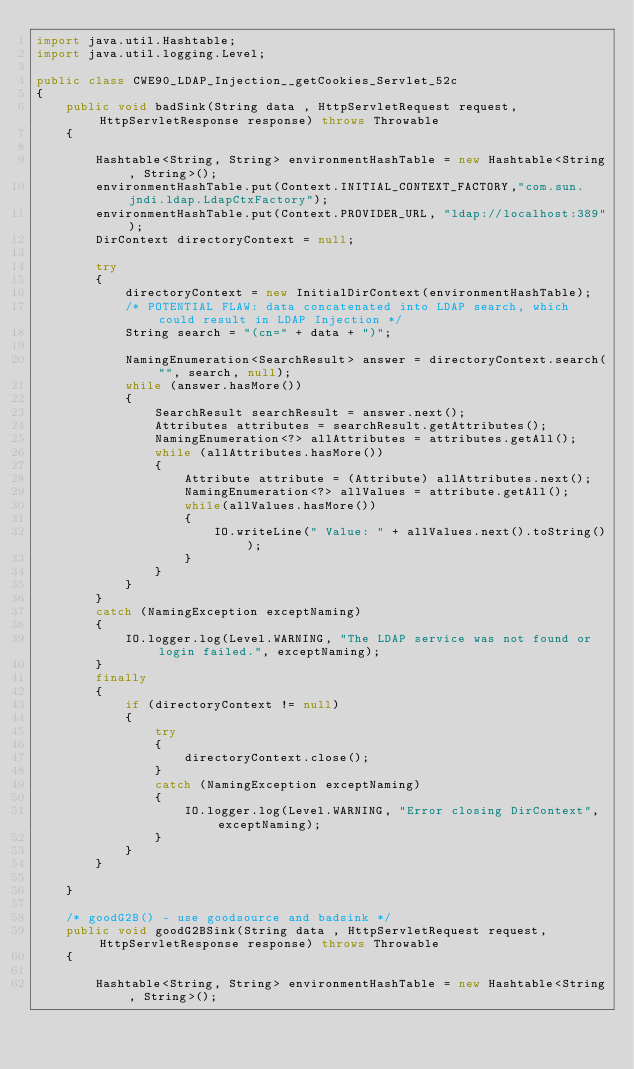Convert code to text. <code><loc_0><loc_0><loc_500><loc_500><_Java_>import java.util.Hashtable;
import java.util.logging.Level;

public class CWE90_LDAP_Injection__getCookies_Servlet_52c
{
    public void badSink(String data , HttpServletRequest request, HttpServletResponse response) throws Throwable
    {

        Hashtable<String, String> environmentHashTable = new Hashtable<String, String>();
        environmentHashTable.put(Context.INITIAL_CONTEXT_FACTORY,"com.sun.jndi.ldap.LdapCtxFactory");
        environmentHashTable.put(Context.PROVIDER_URL, "ldap://localhost:389");
        DirContext directoryContext = null;

        try
        {
            directoryContext = new InitialDirContext(environmentHashTable);
            /* POTENTIAL FLAW: data concatenated into LDAP search, which could result in LDAP Injection */
            String search = "(cn=" + data + ")";

            NamingEnumeration<SearchResult> answer = directoryContext.search("", search, null);
            while (answer.hasMore())
            {
                SearchResult searchResult = answer.next();
                Attributes attributes = searchResult.getAttributes();
                NamingEnumeration<?> allAttributes = attributes.getAll();
                while (allAttributes.hasMore())
                {
                    Attribute attribute = (Attribute) allAttributes.next();
                    NamingEnumeration<?> allValues = attribute.getAll();
                    while(allValues.hasMore())
                    {
                        IO.writeLine(" Value: " + allValues.next().toString());
                    }
                }
            }
        }
        catch (NamingException exceptNaming)
        {
            IO.logger.log(Level.WARNING, "The LDAP service was not found or login failed.", exceptNaming);
        }
        finally
        {
            if (directoryContext != null)
            {
                try
                {
                    directoryContext.close();
                }
                catch (NamingException exceptNaming)
                {
                    IO.logger.log(Level.WARNING, "Error closing DirContext", exceptNaming);
                }
            }
        }

    }

    /* goodG2B() - use goodsource and badsink */
    public void goodG2BSink(String data , HttpServletRequest request, HttpServletResponse response) throws Throwable
    {

        Hashtable<String, String> environmentHashTable = new Hashtable<String, String>();</code> 